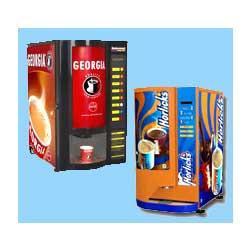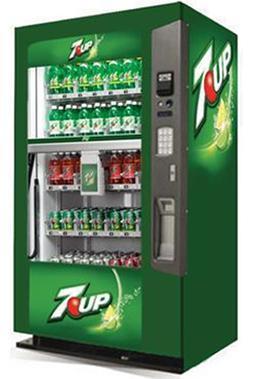The first image is the image on the left, the second image is the image on the right. Analyze the images presented: Is the assertion "An image features a standalone vending machine with greenish sides that include a logo towards the top." valid? Answer yes or no. Yes. The first image is the image on the left, the second image is the image on the right. Assess this claim about the two images: "The vending machine in the right image is predominately green.". Correct or not? Answer yes or no. Yes. 